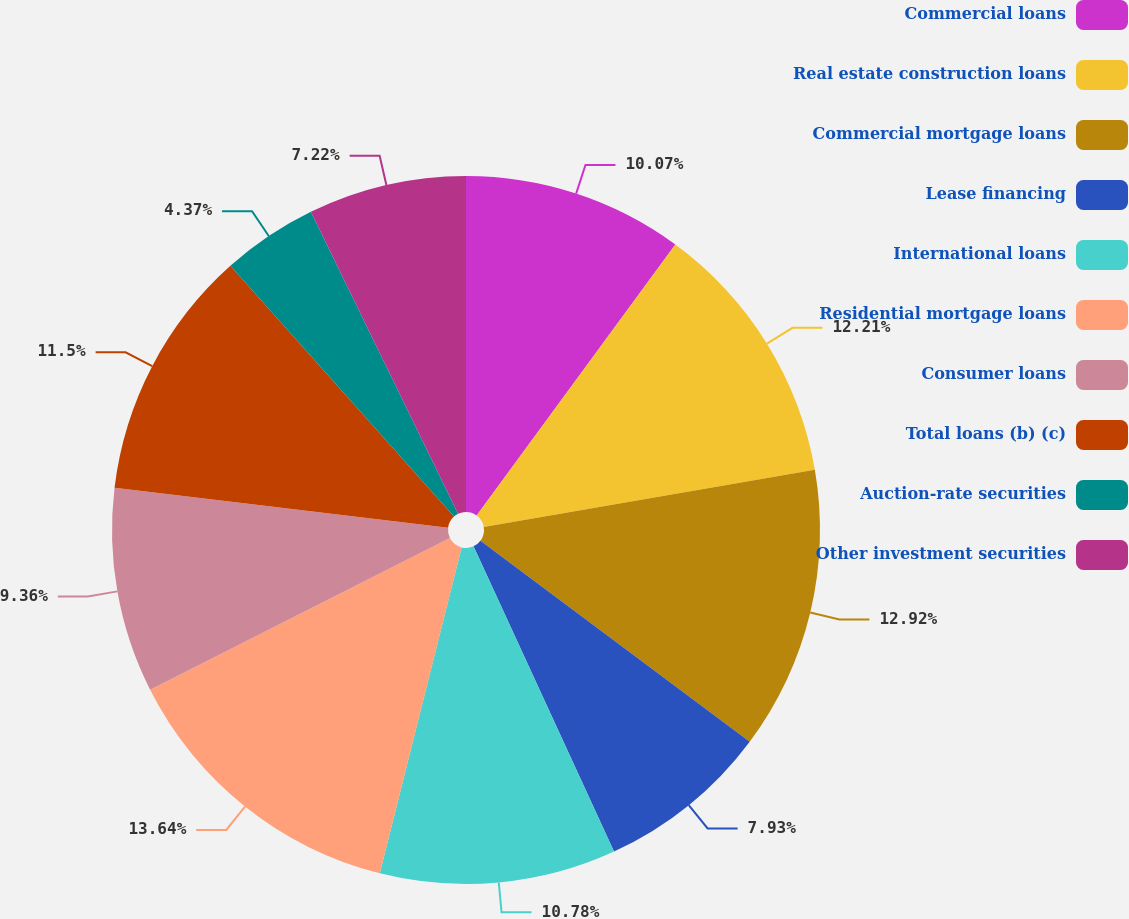Convert chart to OTSL. <chart><loc_0><loc_0><loc_500><loc_500><pie_chart><fcel>Commercial loans<fcel>Real estate construction loans<fcel>Commercial mortgage loans<fcel>Lease financing<fcel>International loans<fcel>Residential mortgage loans<fcel>Consumer loans<fcel>Total loans (b) (c)<fcel>Auction-rate securities<fcel>Other investment securities<nl><fcel>10.07%<fcel>12.21%<fcel>12.92%<fcel>7.93%<fcel>10.78%<fcel>13.63%<fcel>9.36%<fcel>11.5%<fcel>4.37%<fcel>7.22%<nl></chart> 